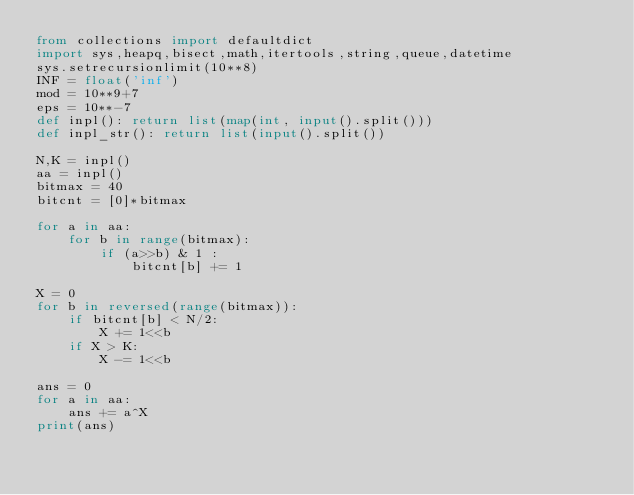Convert code to text. <code><loc_0><loc_0><loc_500><loc_500><_Python_>from collections import defaultdict
import sys,heapq,bisect,math,itertools,string,queue,datetime
sys.setrecursionlimit(10**8)
INF = float('inf')
mod = 10**9+7
eps = 10**-7
def inpl(): return list(map(int, input().split()))
def inpl_str(): return list(input().split())

N,K = inpl()
aa = inpl()
bitmax = 40
bitcnt = [0]*bitmax

for a in aa:
    for b in range(bitmax):
        if (a>>b) & 1 :
            bitcnt[b] += 1

X = 0
for b in reversed(range(bitmax)):
    if bitcnt[b] < N/2:
        X += 1<<b
    if X > K:
        X -= 1<<b

ans = 0
for a in aa:
    ans += a^X
print(ans)
</code> 